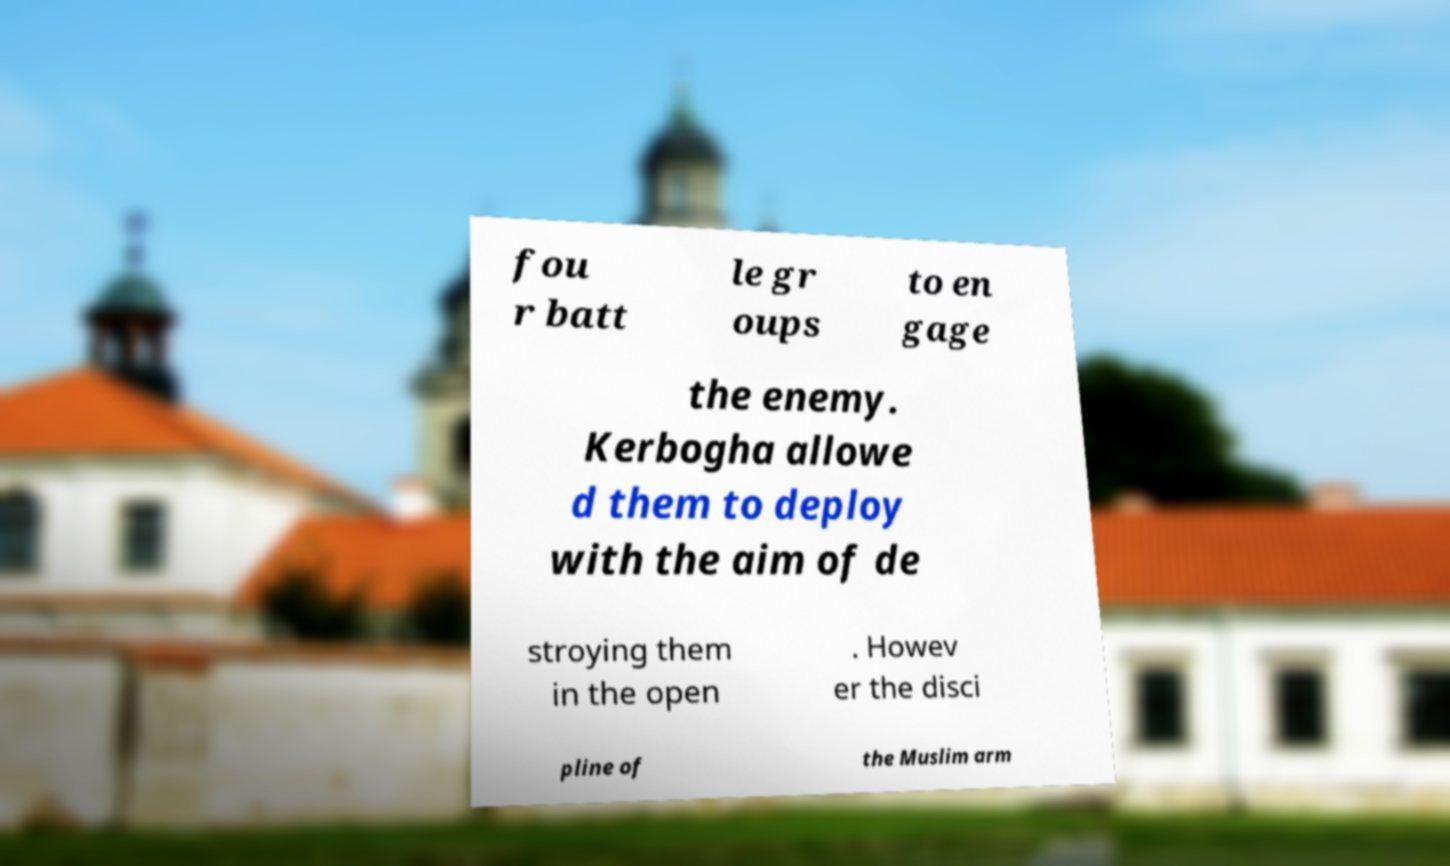Could you assist in decoding the text presented in this image and type it out clearly? fou r batt le gr oups to en gage the enemy. Kerbogha allowe d them to deploy with the aim of de stroying them in the open . Howev er the disci pline of the Muslim arm 